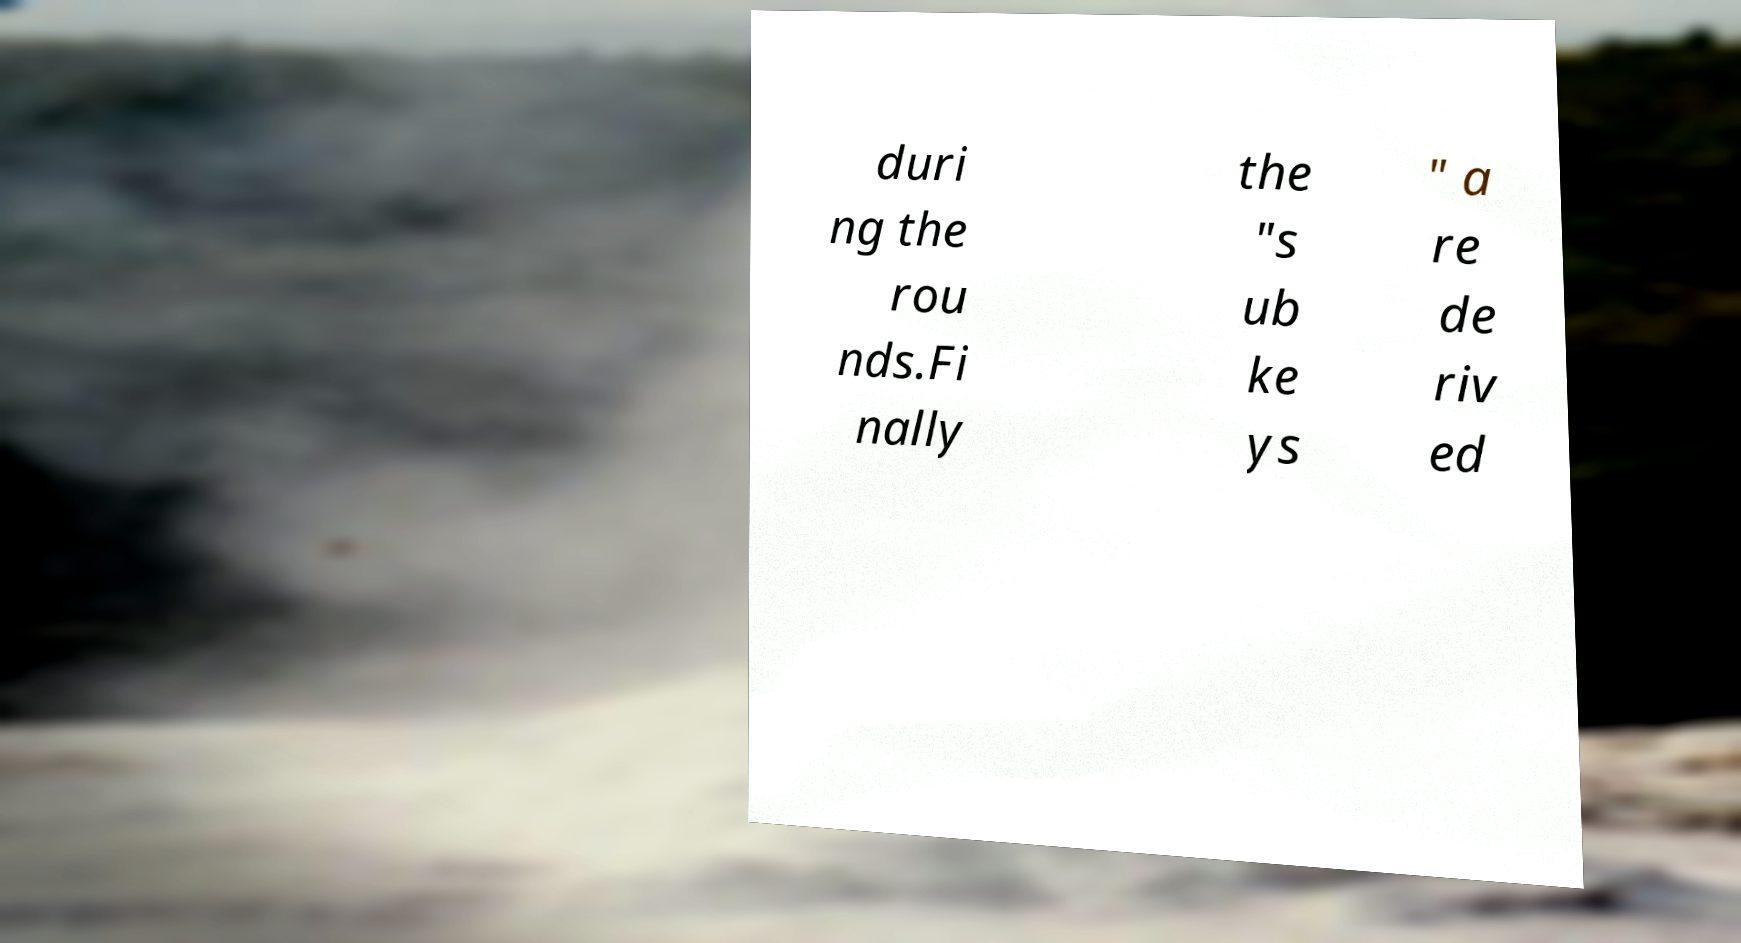Can you accurately transcribe the text from the provided image for me? duri ng the rou nds.Fi nally the "s ub ke ys " a re de riv ed 